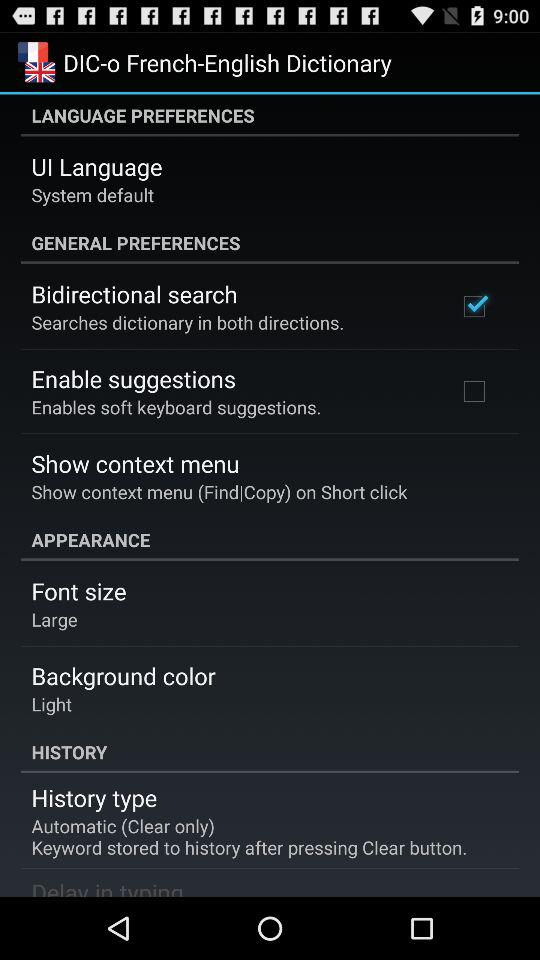What is the "Background color"? The "Background color" is "Light". 